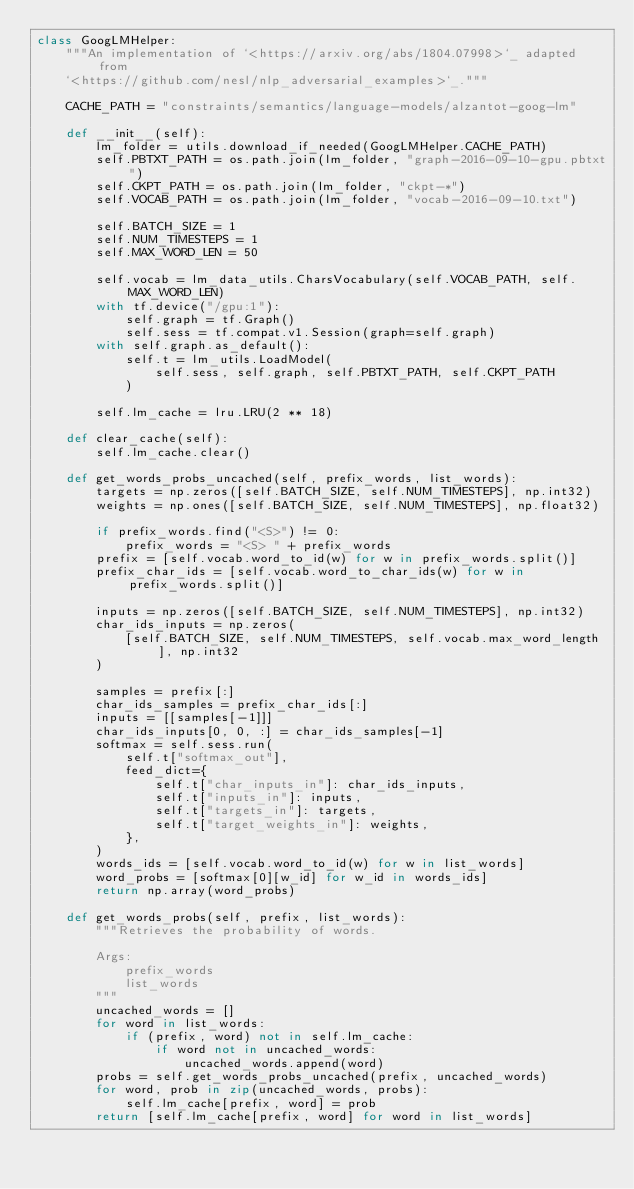Convert code to text. <code><loc_0><loc_0><loc_500><loc_500><_Python_>class GoogLMHelper:
    """An implementation of `<https://arxiv.org/abs/1804.07998>`_ adapted from
    `<https://github.com/nesl/nlp_adversarial_examples>`_."""

    CACHE_PATH = "constraints/semantics/language-models/alzantot-goog-lm"

    def __init__(self):
        lm_folder = utils.download_if_needed(GoogLMHelper.CACHE_PATH)
        self.PBTXT_PATH = os.path.join(lm_folder, "graph-2016-09-10-gpu.pbtxt")
        self.CKPT_PATH = os.path.join(lm_folder, "ckpt-*")
        self.VOCAB_PATH = os.path.join(lm_folder, "vocab-2016-09-10.txt")

        self.BATCH_SIZE = 1
        self.NUM_TIMESTEPS = 1
        self.MAX_WORD_LEN = 50

        self.vocab = lm_data_utils.CharsVocabulary(self.VOCAB_PATH, self.MAX_WORD_LEN)
        with tf.device("/gpu:1"):
            self.graph = tf.Graph()
            self.sess = tf.compat.v1.Session(graph=self.graph)
        with self.graph.as_default():
            self.t = lm_utils.LoadModel(
                self.sess, self.graph, self.PBTXT_PATH, self.CKPT_PATH
            )

        self.lm_cache = lru.LRU(2 ** 18)

    def clear_cache(self):
        self.lm_cache.clear()

    def get_words_probs_uncached(self, prefix_words, list_words):
        targets = np.zeros([self.BATCH_SIZE, self.NUM_TIMESTEPS], np.int32)
        weights = np.ones([self.BATCH_SIZE, self.NUM_TIMESTEPS], np.float32)

        if prefix_words.find("<S>") != 0:
            prefix_words = "<S> " + prefix_words
        prefix = [self.vocab.word_to_id(w) for w in prefix_words.split()]
        prefix_char_ids = [self.vocab.word_to_char_ids(w) for w in prefix_words.split()]

        inputs = np.zeros([self.BATCH_SIZE, self.NUM_TIMESTEPS], np.int32)
        char_ids_inputs = np.zeros(
            [self.BATCH_SIZE, self.NUM_TIMESTEPS, self.vocab.max_word_length], np.int32
        )

        samples = prefix[:]
        char_ids_samples = prefix_char_ids[:]
        inputs = [[samples[-1]]]
        char_ids_inputs[0, 0, :] = char_ids_samples[-1]
        softmax = self.sess.run(
            self.t["softmax_out"],
            feed_dict={
                self.t["char_inputs_in"]: char_ids_inputs,
                self.t["inputs_in"]: inputs,
                self.t["targets_in"]: targets,
                self.t["target_weights_in"]: weights,
            },
        )
        words_ids = [self.vocab.word_to_id(w) for w in list_words]
        word_probs = [softmax[0][w_id] for w_id in words_ids]
        return np.array(word_probs)

    def get_words_probs(self, prefix, list_words):
        """Retrieves the probability of words.

        Args:
            prefix_words
            list_words
        """
        uncached_words = []
        for word in list_words:
            if (prefix, word) not in self.lm_cache:
                if word not in uncached_words:
                    uncached_words.append(word)
        probs = self.get_words_probs_uncached(prefix, uncached_words)
        for word, prob in zip(uncached_words, probs):
            self.lm_cache[prefix, word] = prob
        return [self.lm_cache[prefix, word] for word in list_words]
</code> 